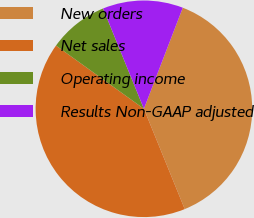Convert chart. <chart><loc_0><loc_0><loc_500><loc_500><pie_chart><fcel>New orders<fcel>Net sales<fcel>Operating income<fcel>Results Non-GAAP adjusted<nl><fcel>38.0%<fcel>41.08%<fcel>8.92%<fcel>12.0%<nl></chart> 